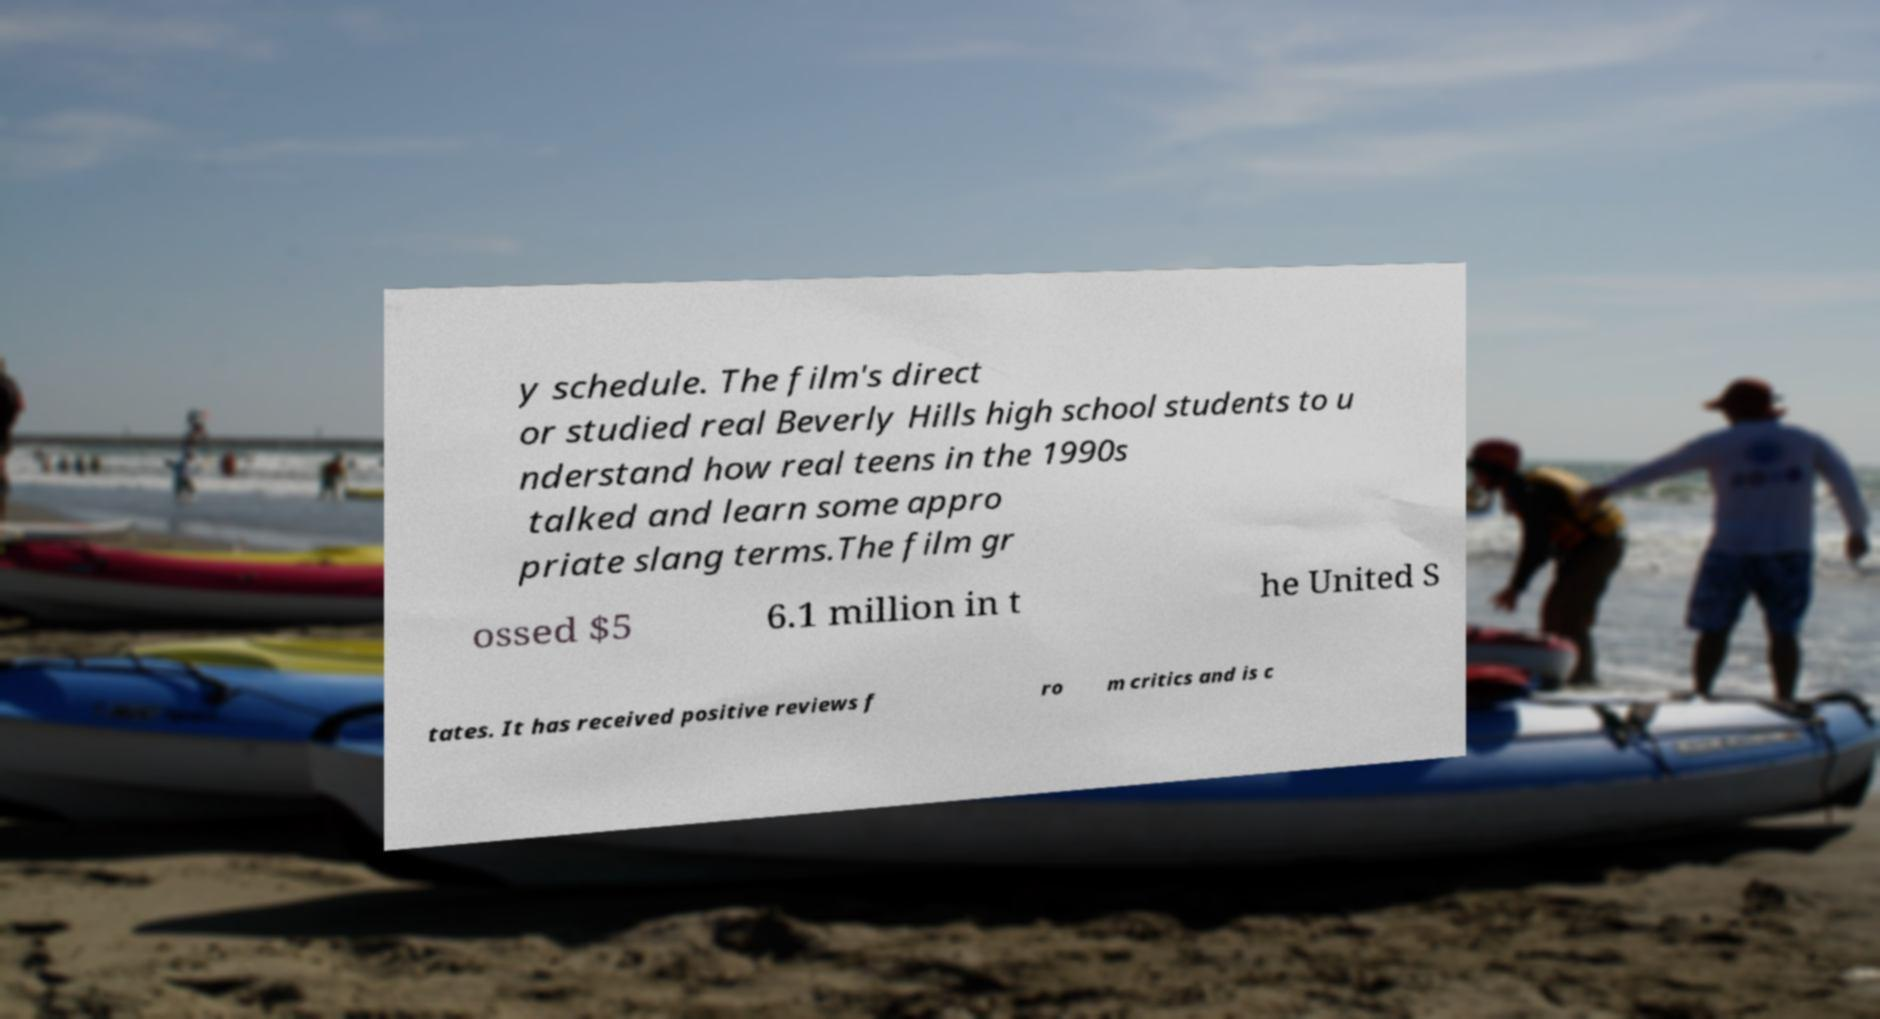What messages or text are displayed in this image? I need them in a readable, typed format. y schedule. The film's direct or studied real Beverly Hills high school students to u nderstand how real teens in the 1990s talked and learn some appro priate slang terms.The film gr ossed $5 6.1 million in t he United S tates. It has received positive reviews f ro m critics and is c 